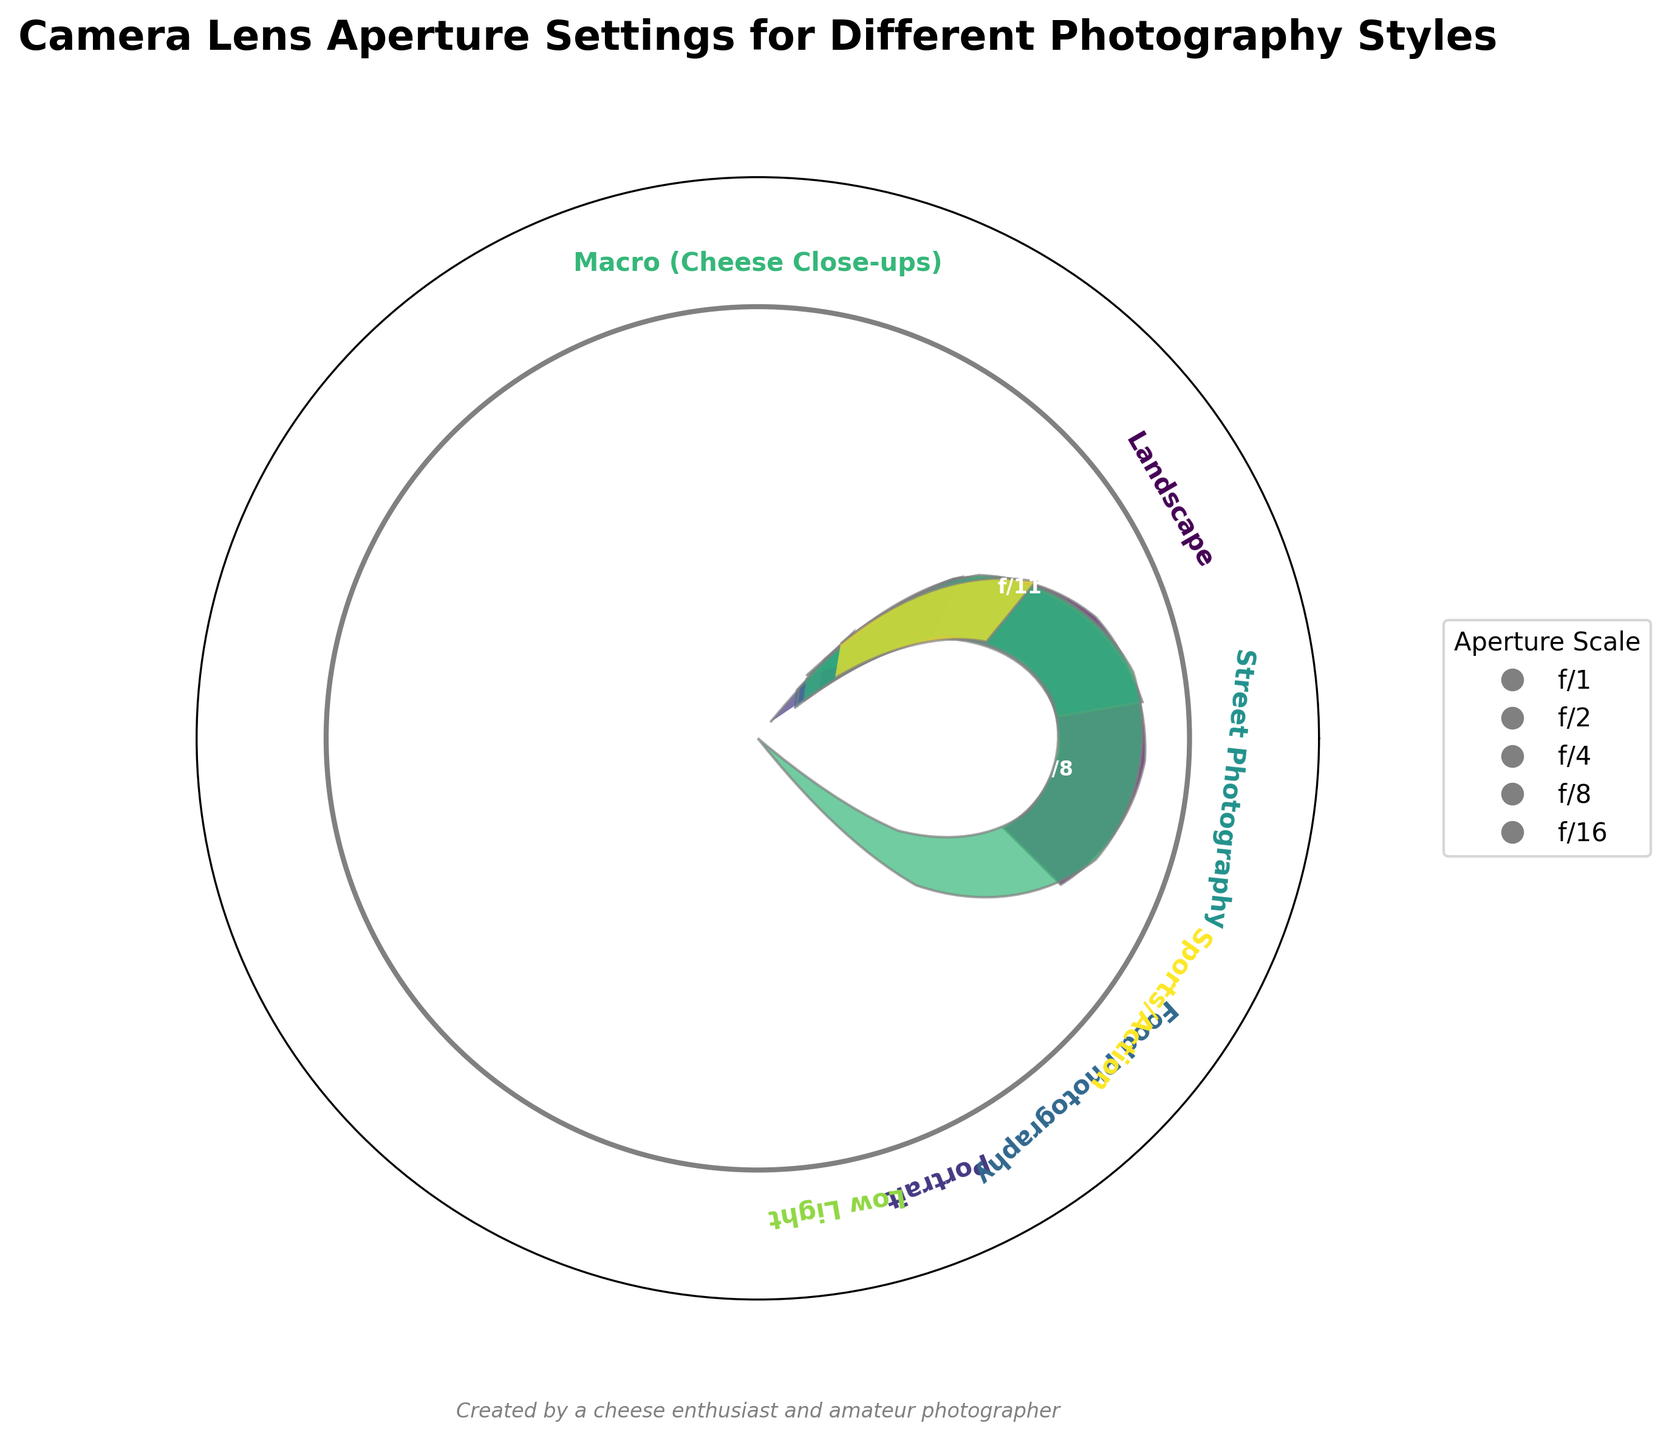Which photography style uses the smallest aperture setting? The gauge that has the smallest angle on the radial axis denotes the smallest aperture. The style labeled "Macro (Cheese Close-ups)" with an aperture setting of f/16 has the smallest aperture.
Answer: Macro (Cheese Close-ups) Which style has the largest aperture setting? The gauge with the largest angle on the radial axis represents the largest aperture. The style labeled "Low Light" has the largest aperture with a setting of f/1.8.
Answer: Low Light What is the title of the plot? The title of the plot is displayed at the top of the figure. It reads "Camera Lens Aperture Settings for Different Photography Styles."
Answer: Camera Lens Aperture Settings for Different Photography Styles Which styles have an aperture setting close to f/8? By locating styles with an aperture setting near the midpoint of the radial axis (f/8), we find "Street Photography" labeled with an aperture of f/8.
Answer: Street Photography How many photography styles are displayed in the plot? Count the number of distinct labels presented in the gauge plot. There are seven different labels, indicating seven photography styles.
Answer: Seven What is the aperture range represented in the plot? By observing the minimum and maximum aperture values on the radial gauges, the range is from f/1.8 to f/16.
Answer: f/1.8 to f/16 Compare the aperture settings for "Portrait" and "Landscape" photography. Which one uses a larger aperture? Locate the gauges for both "Portrait" and "Landscape" styles. "Portrait" uses f/2.8 and "Landscape" uses f/11. Since f/2.8 is larger than f/11, "Portrait" uses a larger aperture.
Answer: Portrait Which photography style uses the medium value of all given aperture settings? The aperture settings in ascending order are: f/1.8, f/2.8, f/4.5, f/5.6, f/8, f/11, f/16. The median value is the fourth value f/5.6, which corresponds to "Sports/Action" style.
Answer: Sports/Action What do the colors in the gauge chart represent? The colors in the gauges correspond to different photography styles, helping to distinguish between each style.
Answer: Different photography styles What kind of border surrounds the gauges in the plot? A circular border encapsulates the gauges, delineated by a gray line.
Answer: Circular 